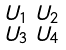<formula> <loc_0><loc_0><loc_500><loc_500>\begin{smallmatrix} U _ { 1 } & U _ { 2 } \\ U _ { 3 } & U _ { 4 } \end{smallmatrix}</formula> 